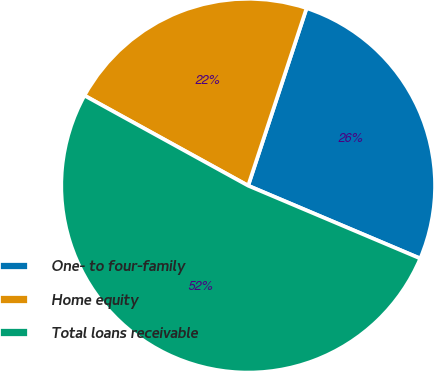Convert chart to OTSL. <chart><loc_0><loc_0><loc_500><loc_500><pie_chart><fcel>One- to four-family<fcel>Home equity<fcel>Total loans receivable<nl><fcel>26.31%<fcel>22.05%<fcel>51.64%<nl></chart> 